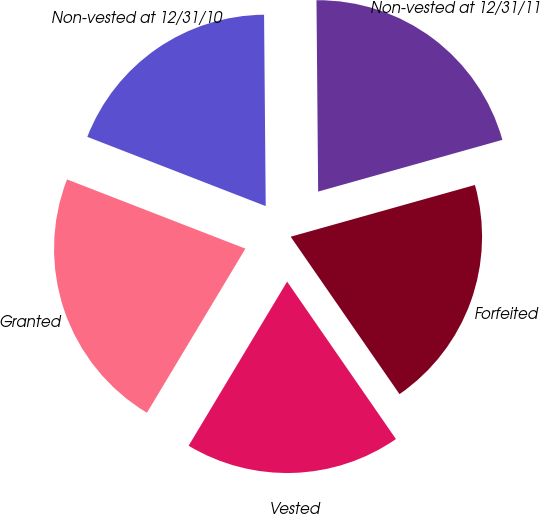<chart> <loc_0><loc_0><loc_500><loc_500><pie_chart><fcel>Non-vested at 12/31/10<fcel>Granted<fcel>Vested<fcel>Forfeited<fcel>Non-vested at 12/31/11<nl><fcel>18.97%<fcel>22.29%<fcel>18.23%<fcel>19.73%<fcel>20.78%<nl></chart> 